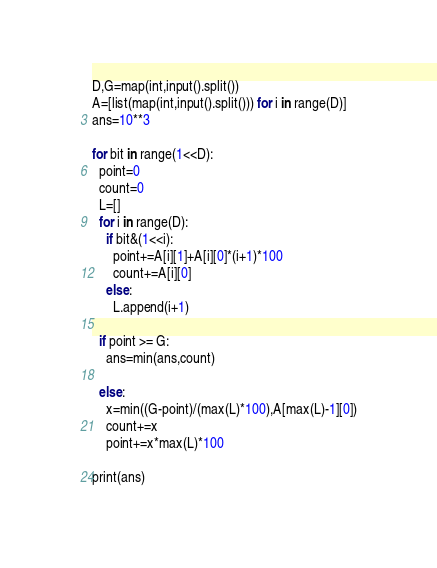Convert code to text. <code><loc_0><loc_0><loc_500><loc_500><_Python_>D,G=map(int,input().split())
A=[list(map(int,input().split())) for i in range(D)]
ans=10**3

for bit in range(1<<D):
  point=0
  count=0
  L=[]
  for i in range(D):
    if bit&(1<<i):
      point+=A[i][1]+A[i][0]*(i+1)*100
      count+=A[i][0]
    else:
      L.append(i+1)
      
  if point >= G:
    ans=min(ans,count)
    
  else:
    x=min((G-point)/(max(L)*100),A[max(L)-1][0])
    count+=x
    point+=x*max(L)*100
  
print(ans) </code> 